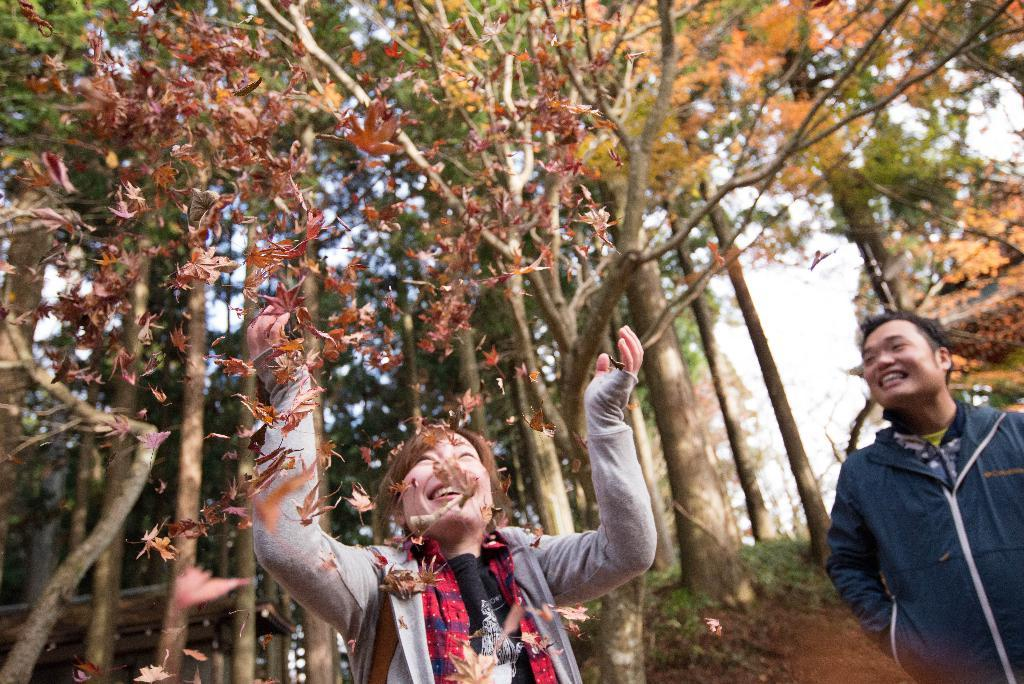How many people are in the image? There are two people in the image: a man and a woman. What is the woman doing in the image? The woman is throwing dry leaves upwards and playing with the leaves. What can be seen in the background of the image? There are many tall trees in the background of the image. Where can the seashore be seen in the image? There is no seashore visible in the image; it features a woman playing with dry leaves and tall trees in the background. What type of stamp is being exchanged between the man and woman in the image? There is no stamp exchange depicted in the image; it shows a woman playing with dry leaves and a man standing nearby. 